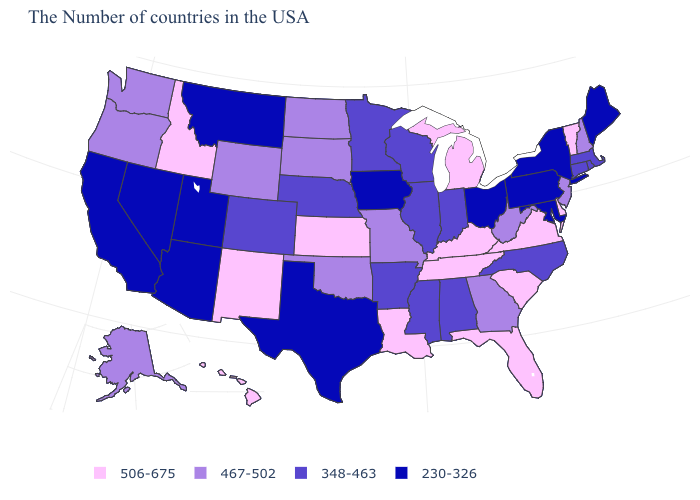How many symbols are there in the legend?
Concise answer only. 4. What is the value of Connecticut?
Answer briefly. 348-463. Name the states that have a value in the range 230-326?
Write a very short answer. Maine, New York, Maryland, Pennsylvania, Ohio, Iowa, Texas, Utah, Montana, Arizona, Nevada, California. Which states hav the highest value in the West?
Quick response, please. New Mexico, Idaho, Hawaii. Among the states that border South Dakota , which have the lowest value?
Quick response, please. Iowa, Montana. Does the map have missing data?
Quick response, please. No. What is the value of New Mexico?
Quick response, please. 506-675. Which states have the lowest value in the USA?
Concise answer only. Maine, New York, Maryland, Pennsylvania, Ohio, Iowa, Texas, Utah, Montana, Arizona, Nevada, California. What is the value of Connecticut?
Concise answer only. 348-463. How many symbols are there in the legend?
Answer briefly. 4. What is the lowest value in the USA?
Give a very brief answer. 230-326. What is the lowest value in the USA?
Give a very brief answer. 230-326. Does Delaware have the highest value in the South?
Answer briefly. Yes. What is the value of Maryland?
Keep it brief. 230-326. What is the value of Kentucky?
Short answer required. 506-675. 